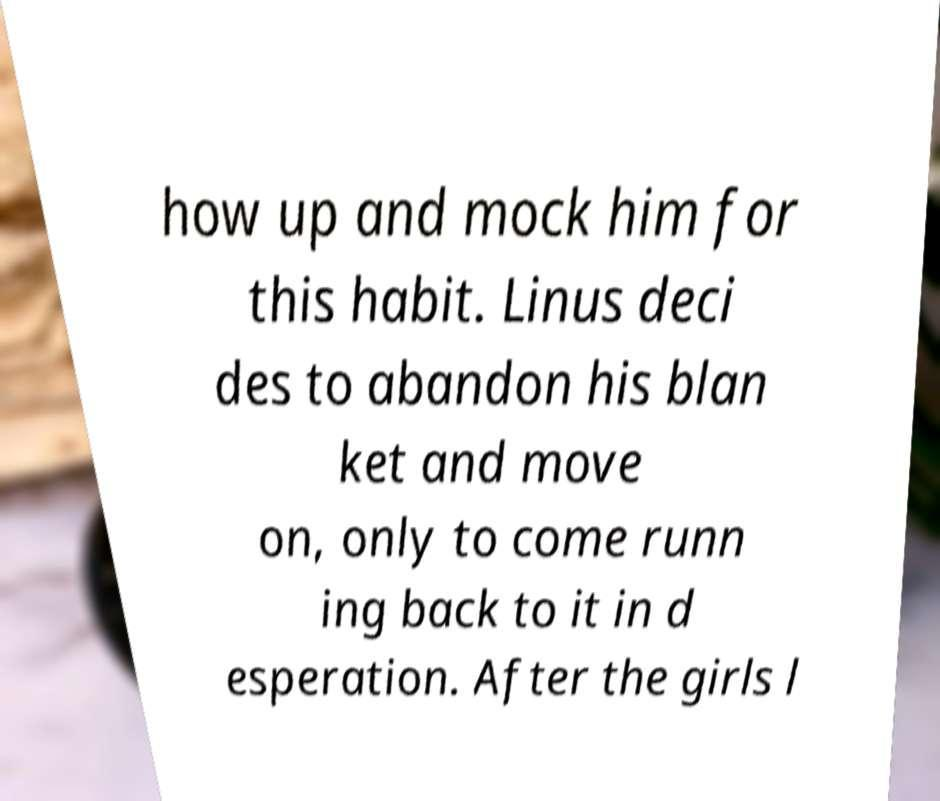Can you read and provide the text displayed in the image?This photo seems to have some interesting text. Can you extract and type it out for me? how up and mock him for this habit. Linus deci des to abandon his blan ket and move on, only to come runn ing back to it in d esperation. After the girls l 